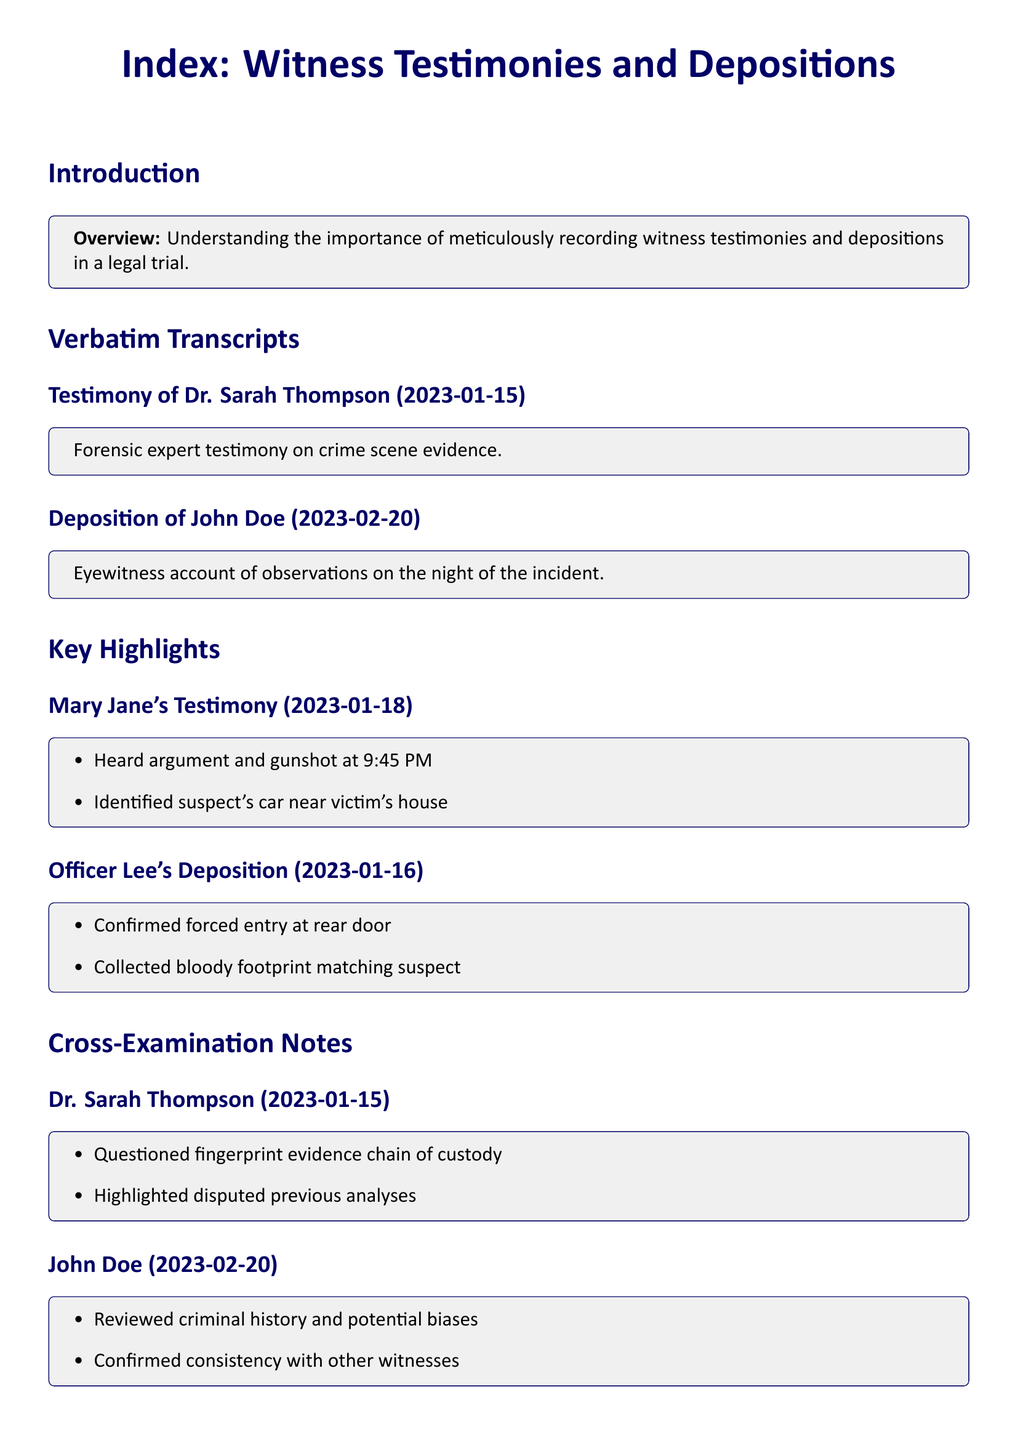What is the date of Dr. Sarah Thompson's testimony? The document specifies the date of Dr. Sarah Thompson's testimony as January 15, 2023.
Answer: January 15, 2023 Who provided eyewitness testimony? The deposition indicates that John Doe provided an eyewitness account of the incident.
Answer: John Doe What evidence did Officer Lee confirm? Officer Lee confirmed forced entry at the rear door as part of his deposition notes.
Answer: Forced entry What time did Mary Jane hear the argument and gunshot? Mary Jane reported hearing the argument and gunshot at 9:45 PM during her testimony.
Answer: 9:45 PM What was questioned during Dr. Sarah Thompson's cross-examination? The cross-examination notes indicate that the chain of custody of fingerprint evidence was questioned.
Answer: Chain of custody How many highlights are noted for Officer Lee's deposition? There are two key highlights noted from Officer Lee's deposition.
Answer: Two What was the date of John Doe's deposition? John Doe's deposition is dated February 20, 2023, as listed in the document.
Answer: February 20, 2023 What method was used to collect evidence by Officer Lee? Officer Lee's deposition mentions that he collected a bloody footprint matching the suspect.
Answer: Collected a bloody footprint What relation does John Doe's consistency have with the testimonies? John Doe's cross-examination noted that he confirmed consistency with other witnesses, indicating his reliability.
Answer: Confirmed consistency with other witnesses 